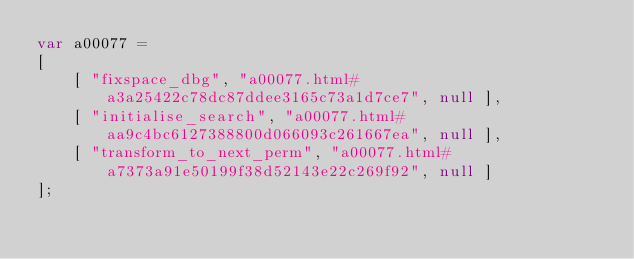<code> <loc_0><loc_0><loc_500><loc_500><_JavaScript_>var a00077 =
[
    [ "fixspace_dbg", "a00077.html#a3a25422c78dc87ddee3165c73a1d7ce7", null ],
    [ "initialise_search", "a00077.html#aa9c4bc6127388800d066093c261667ea", null ],
    [ "transform_to_next_perm", "a00077.html#a7373a91e50199f38d52143e22c269f92", null ]
];</code> 